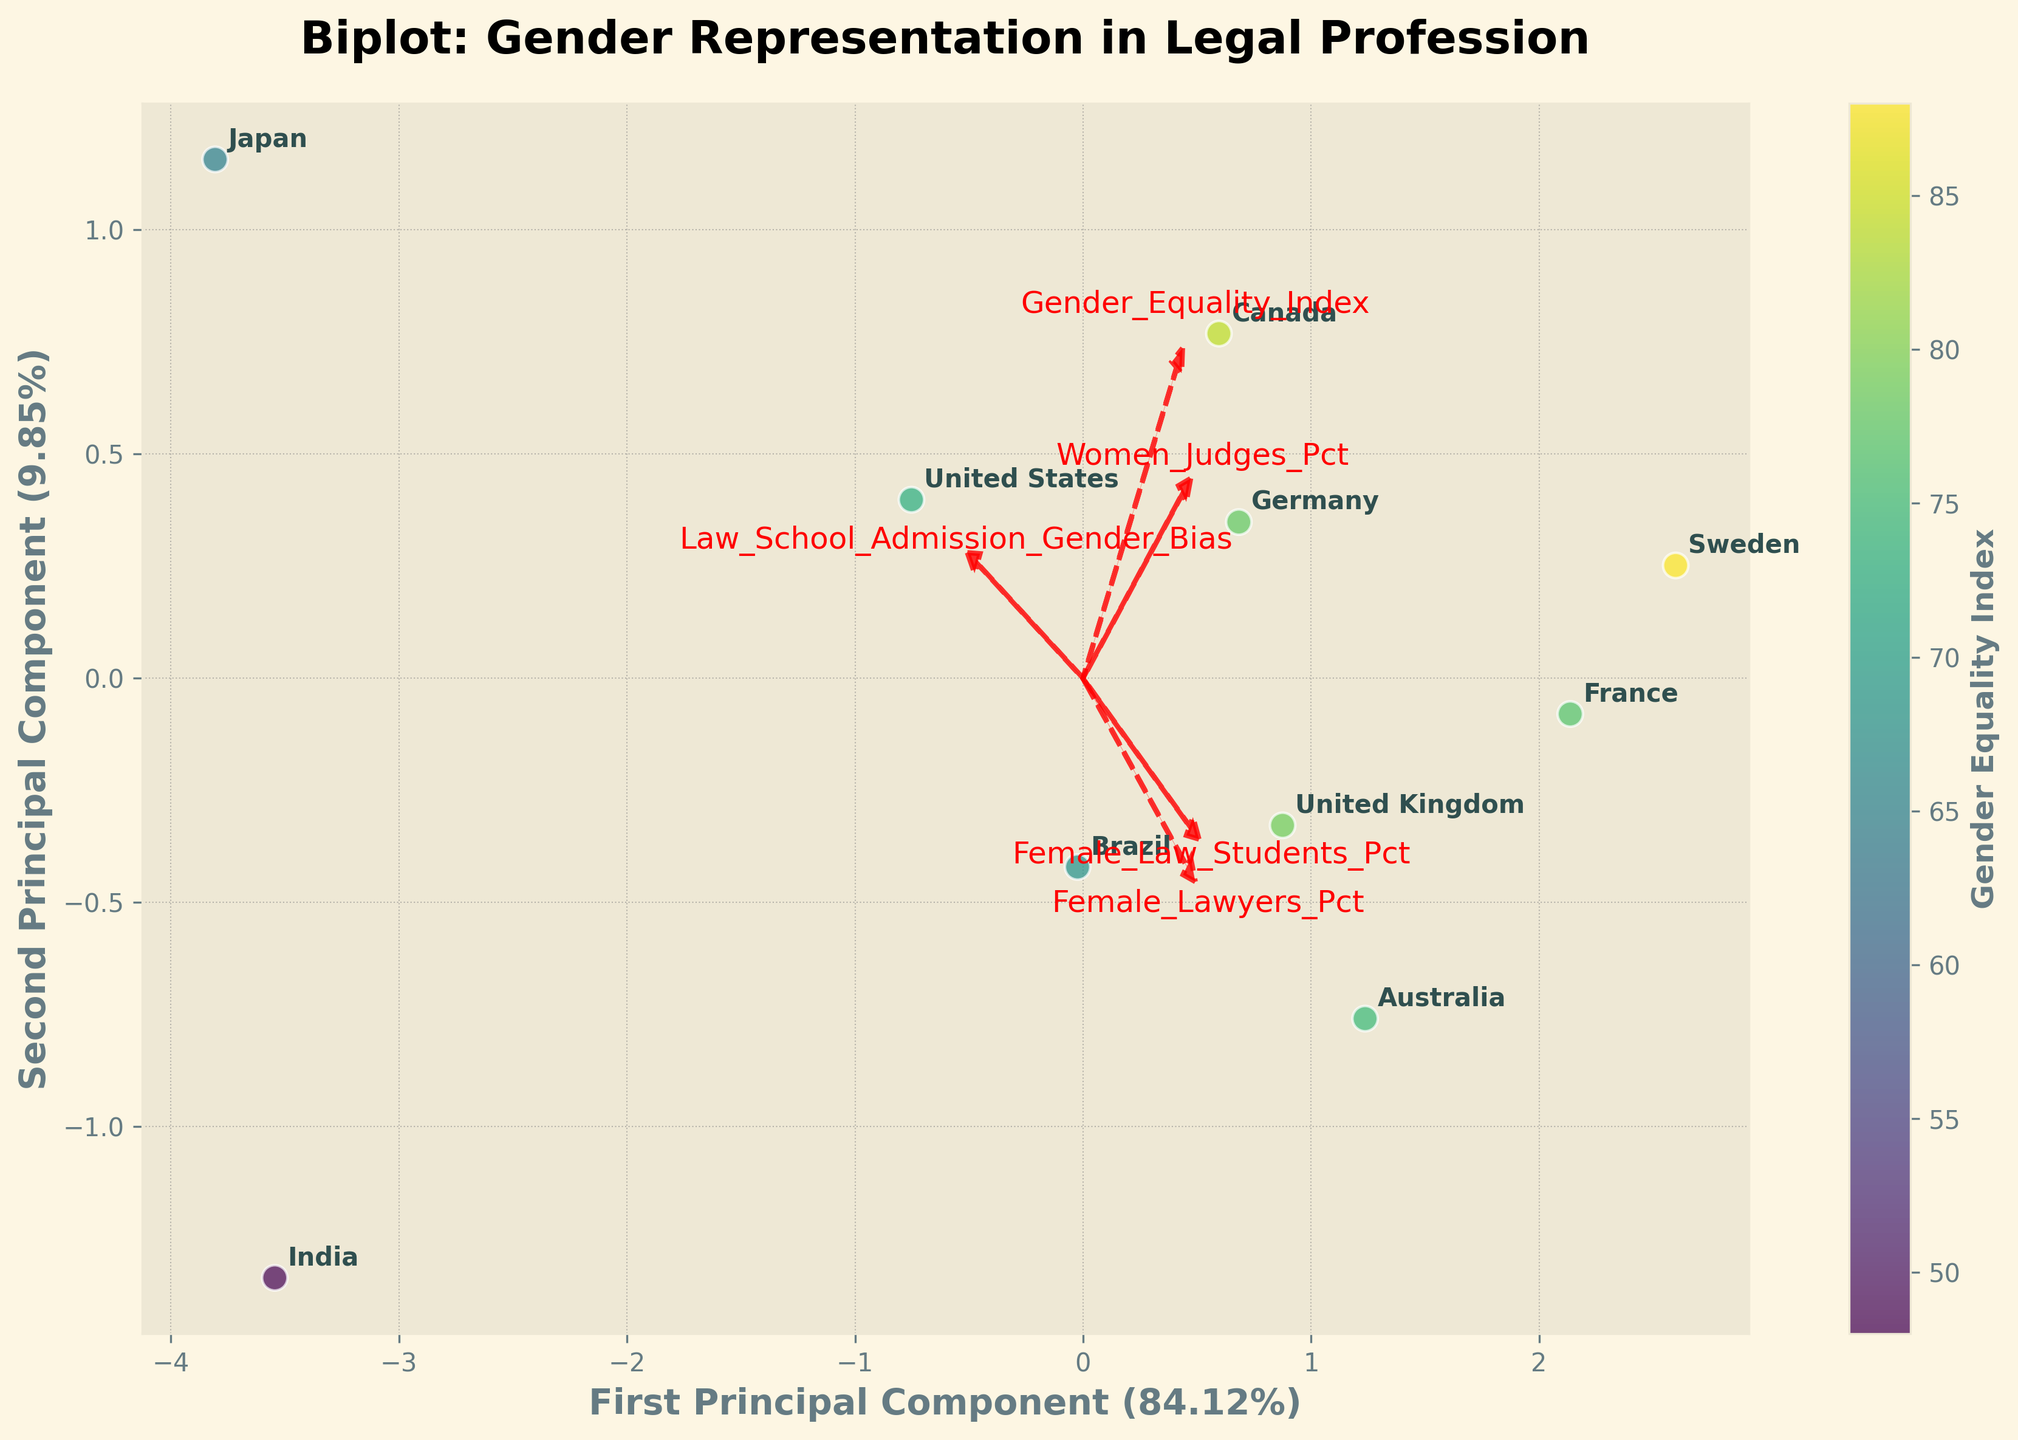What is the title of the plot? The title of the plot is visually found at the top center of the figure and it reads "Biplot: Gender Representation in Legal Profession".
Answer: Biplot: Gender Representation in Legal Profession Which country has the lowest percentage of female lawyers? By looking at the points' labels in the plot, identify the point with the lowest `Female_Lawyers_Pct` on the scatter plot. The annotation "Japan" is closest to the lowest value on the relevant axis.
Answer: Japan What do the arrows in the plot represent? The arrows or vectors in the plot represent the original features in the dataset. Each arrow shows the direction and magnitude that particular feature contributes to the principal components.
Answer: Original features Is there a positive relationship between gender equality index and the percentage of female judges? Observe the scatter plot and check the coloration (indicating Gender Equality Index) alongside the position of points, especially for the trend between `Gender_Equality_Index` and `Women_Judges_Pct`. Points with a higher Gender Equality Index tend to be positioned higher along the 'Women_Judges_Pct' axis.
Answer: Yes Which country has the highest gender equality index and where is it positioned in the biplot? The colorbar indicates that Sweden has the highest gender equality index. The annotated point labeled "Sweden" is positioned more towards the right of the biplot in the positive range of both principal components.
Answer: Sweden; positioned on the right What does the color of the data points represent? The color of the data points is explained by the color bar next to the plot and it represents the Gender Equality Index for each country.
Answer: Gender Equality Index Which feature has the strongest contribution to the first principal component? Look at the arrows representing the features and identify the one with the longest arrowhead in the horizontal direction (first principal component). "Gender_Equality_Index" has the longest arrow vector for the first principal component.
Answer: Gender_Equality_Index Which country has the smallest disparity between female law students and female lawyers? Compare the vertical distance between `Female_Law_Students_Pct` and `Female_Lawyers_Pct` by looking at the plot annotations. France is closest in values, indicating the smallest disparity.
Answer: France Between Japan and India, which country has higher Law School Admission Gender Bias? Inspect the annotation for Japan and India and the corresponding vectors for 'Law_School_Admission_Gender_Bias'. Notice that Japan's point is further towards the vector for 'Law_School_Admission_Gender_Bias'.
Answer: Japan 